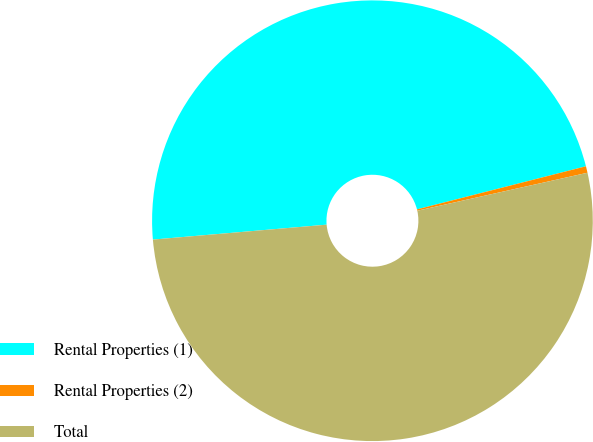<chart> <loc_0><loc_0><loc_500><loc_500><pie_chart><fcel>Rental Properties (1)<fcel>Rental Properties (2)<fcel>Total<nl><fcel>47.39%<fcel>0.48%<fcel>52.13%<nl></chart> 